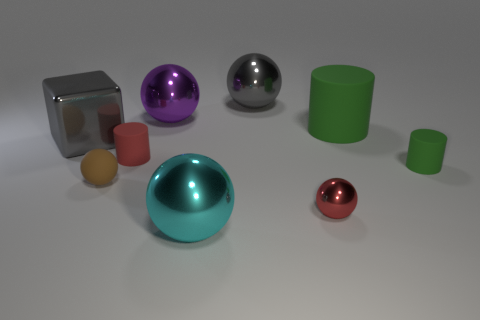Subtract all brown spheres. How many spheres are left? 4 Subtract all cyan cubes. How many green cylinders are left? 2 Add 1 tiny brown rubber spheres. How many objects exist? 10 Subtract all red balls. How many balls are left? 4 Subtract 3 balls. How many balls are left? 2 Subtract all brown cylinders. Subtract all brown balls. How many cylinders are left? 3 Subtract all cylinders. How many objects are left? 6 Subtract all small gray balls. Subtract all blocks. How many objects are left? 8 Add 8 red matte cylinders. How many red matte cylinders are left? 9 Add 4 large cyan metal spheres. How many large cyan metal spheres exist? 5 